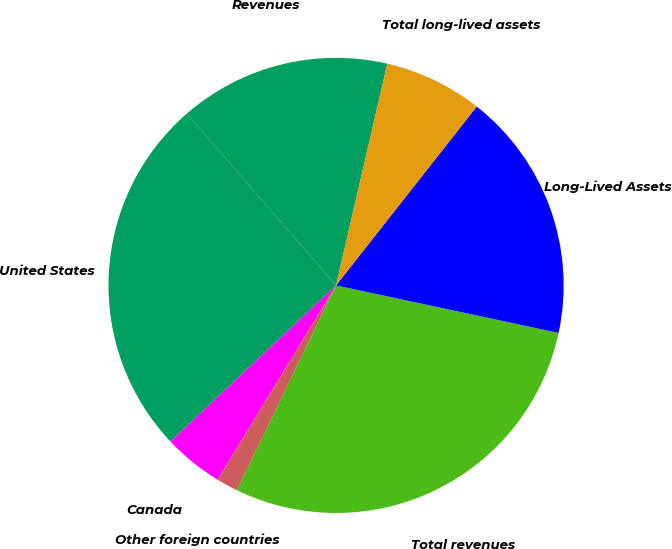<chart> <loc_0><loc_0><loc_500><loc_500><pie_chart><fcel>Revenues<fcel>United States<fcel>Canada<fcel>Other foreign countries<fcel>Total revenues<fcel>Long-Lived Assets<fcel>Total long-lived assets<nl><fcel>15.01%<fcel>25.64%<fcel>4.26%<fcel>1.53%<fcel>28.83%<fcel>17.74%<fcel>6.99%<nl></chart> 